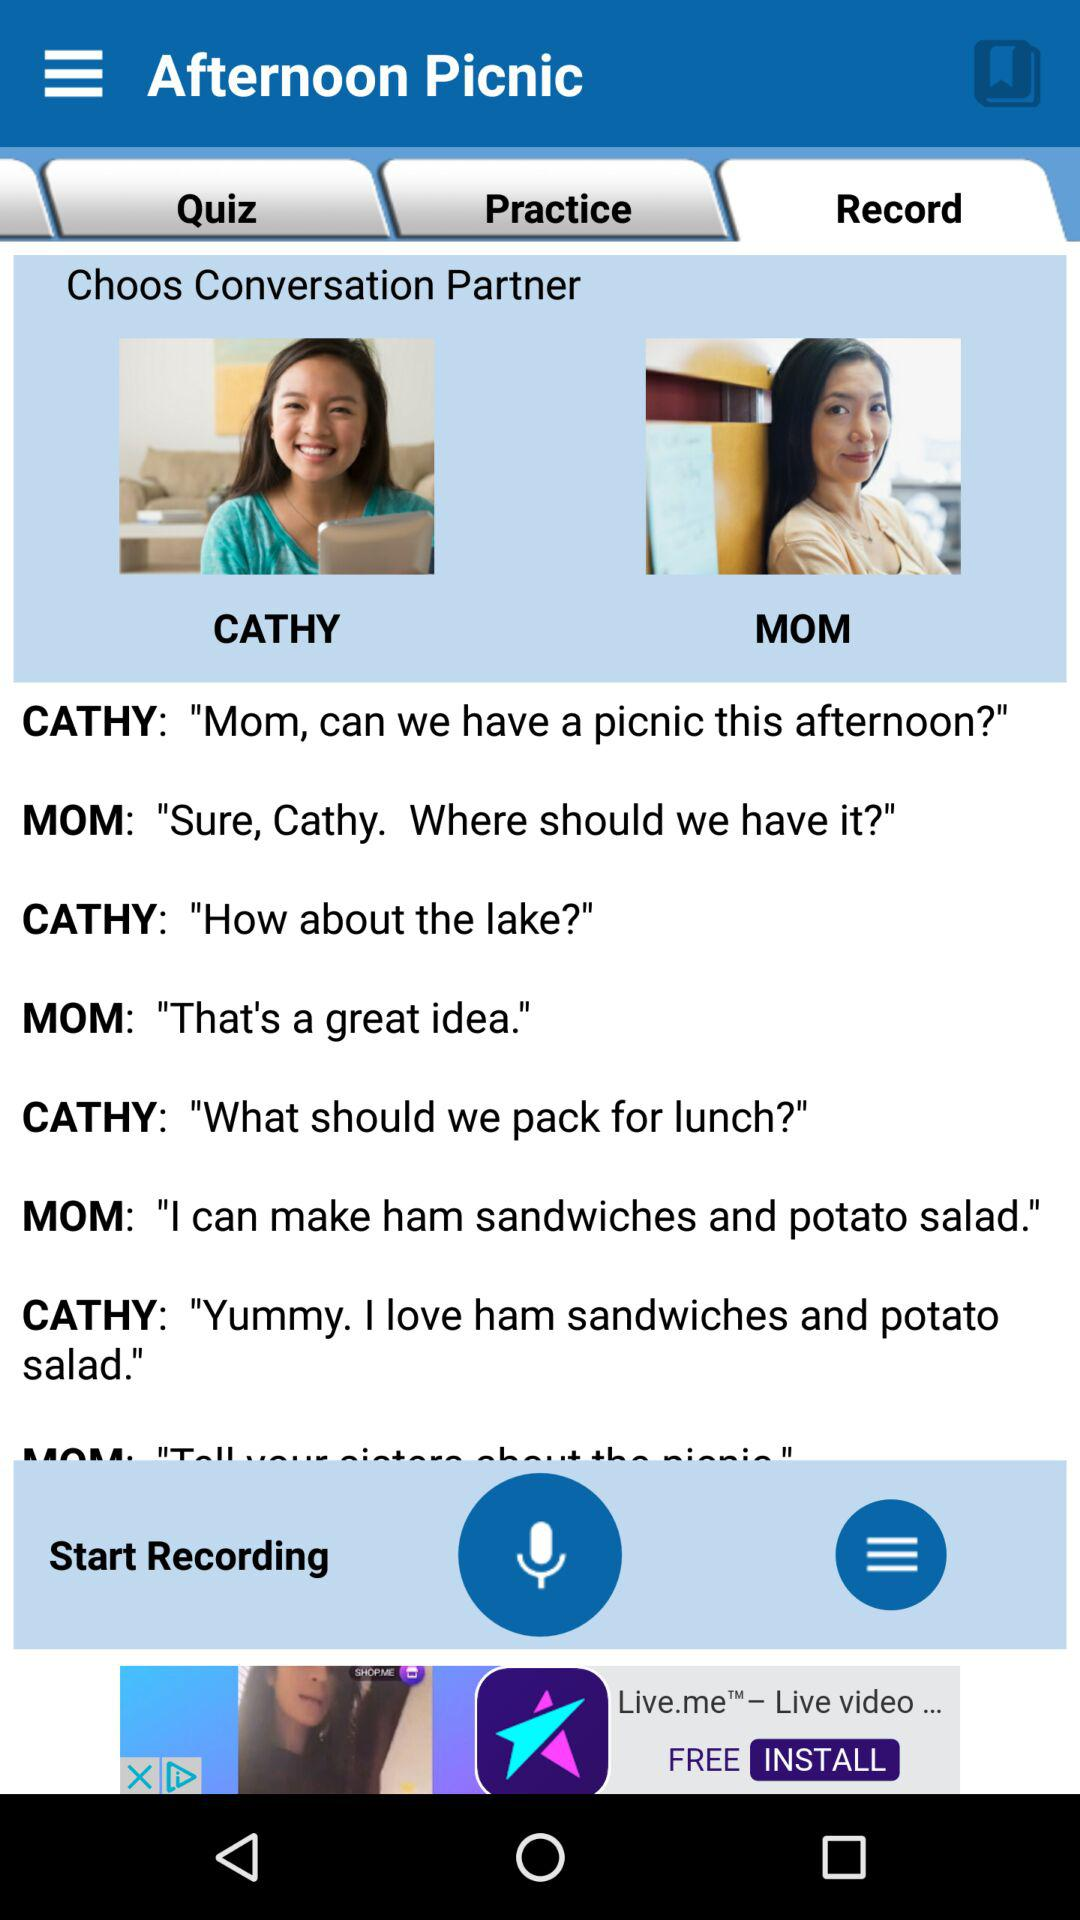How many people are in the conversation?
Answer the question using a single word or phrase. 2 